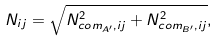<formula> <loc_0><loc_0><loc_500><loc_500>N _ { i j } = \sqrt { N _ { c o m _ { A ^ { \prime } } , i j } ^ { 2 } + N _ { c o m _ { B ^ { \prime } } , i j } ^ { 2 } } ,</formula> 